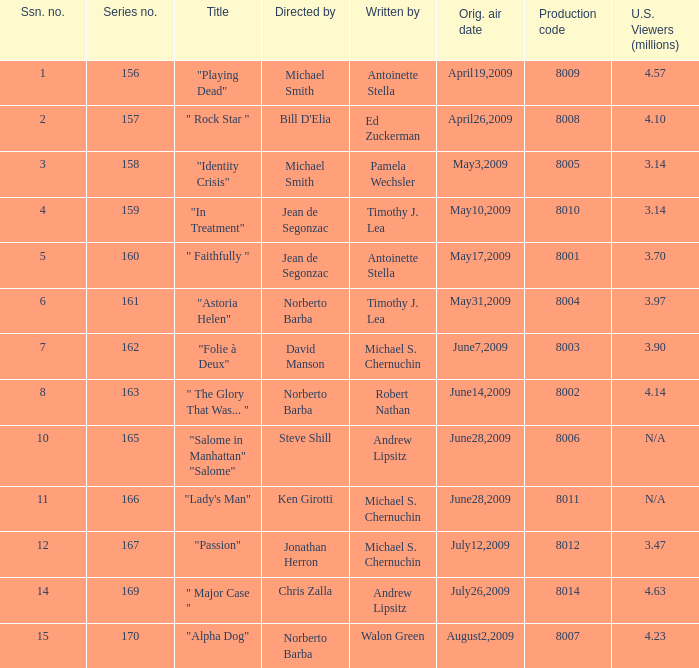What is the name of the episode whose writer is timothy j. lea and the director is norberto barba? "Astoria Helen". Would you mind parsing the complete table? {'header': ['Ssn. no.', 'Series no.', 'Title', 'Directed by', 'Written by', 'Orig. air date', 'Production code', 'U.S. Viewers (millions)'], 'rows': [['1', '156', '"Playing Dead"', 'Michael Smith', 'Antoinette Stella', 'April19,2009', '8009', '4.57'], ['2', '157', '" Rock Star "', "Bill D'Elia", 'Ed Zuckerman', 'April26,2009', '8008', '4.10'], ['3', '158', '"Identity Crisis"', 'Michael Smith', 'Pamela Wechsler', 'May3,2009', '8005', '3.14'], ['4', '159', '"In Treatment"', 'Jean de Segonzac', 'Timothy J. Lea', 'May10,2009', '8010', '3.14'], ['5', '160', '" Faithfully "', 'Jean de Segonzac', 'Antoinette Stella', 'May17,2009', '8001', '3.70'], ['6', '161', '"Astoria Helen"', 'Norberto Barba', 'Timothy J. Lea', 'May31,2009', '8004', '3.97'], ['7', '162', '"Folie à Deux"', 'David Manson', 'Michael S. Chernuchin', 'June7,2009', '8003', '3.90'], ['8', '163', '" The Glory That Was... "', 'Norberto Barba', 'Robert Nathan', 'June14,2009', '8002', '4.14'], ['10', '165', '"Salome in Manhattan" "Salome"', 'Steve Shill', 'Andrew Lipsitz', 'June28,2009', '8006', 'N/A'], ['11', '166', '"Lady\'s Man"', 'Ken Girotti', 'Michael S. Chernuchin', 'June28,2009', '8011', 'N/A'], ['12', '167', '"Passion"', 'Jonathan Herron', 'Michael S. Chernuchin', 'July12,2009', '8012', '3.47'], ['14', '169', '" Major Case "', 'Chris Zalla', 'Andrew Lipsitz', 'July26,2009', '8014', '4.63'], ['15', '170', '"Alpha Dog"', 'Norberto Barba', 'Walon Green', 'August2,2009', '8007', '4.23']]} 